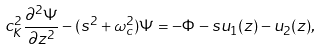Convert formula to latex. <formula><loc_0><loc_0><loc_500><loc_500>c _ { K } ^ { 2 } \frac { \partial ^ { 2 } \Psi } { \partial z ^ { 2 } } - ( s ^ { 2 } + \omega _ { c } ^ { 2 } ) \Psi = - \Phi - s u _ { 1 } ( z ) - u _ { 2 } ( z ) ,</formula> 